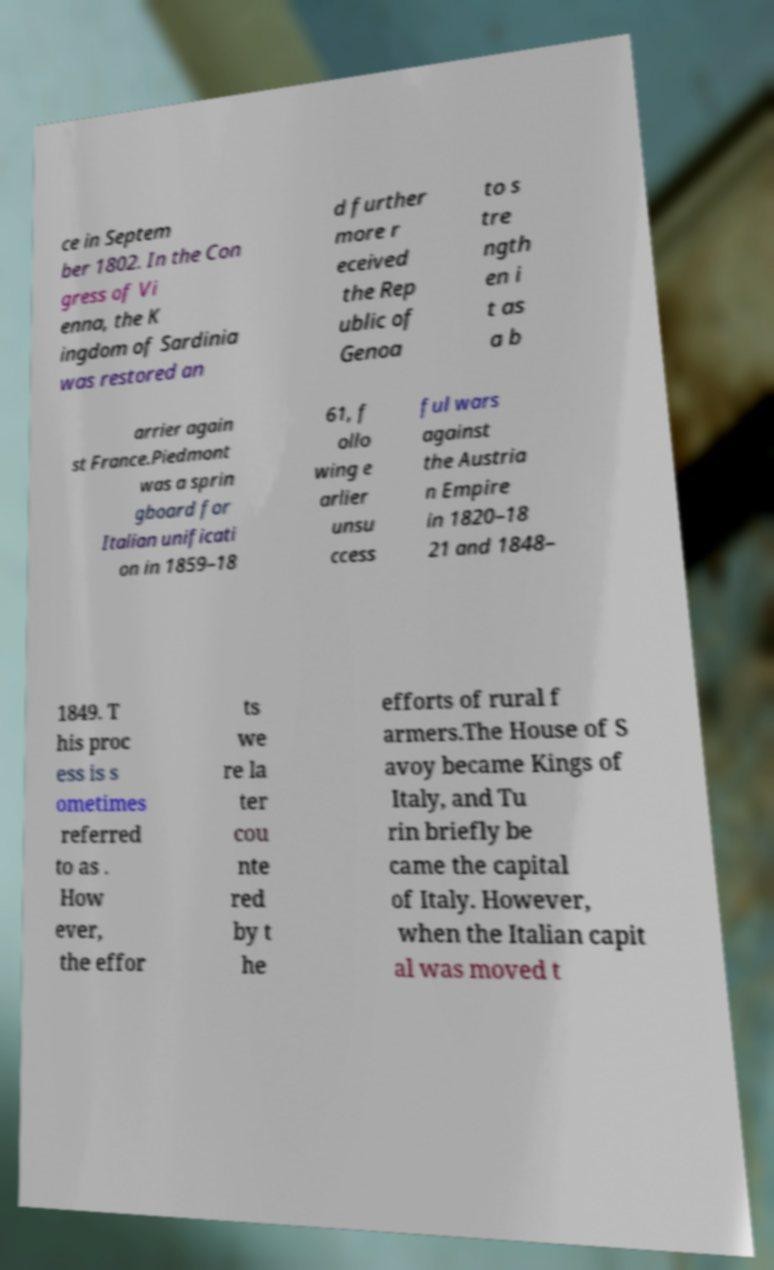For documentation purposes, I need the text within this image transcribed. Could you provide that? ce in Septem ber 1802. In the Con gress of Vi enna, the K ingdom of Sardinia was restored an d further more r eceived the Rep ublic of Genoa to s tre ngth en i t as a b arrier again st France.Piedmont was a sprin gboard for Italian unificati on in 1859–18 61, f ollo wing e arlier unsu ccess ful wars against the Austria n Empire in 1820–18 21 and 1848– 1849. T his proc ess is s ometimes referred to as . How ever, the effor ts we re la ter cou nte red by t he efforts of rural f armers.The House of S avoy became Kings of Italy, and Tu rin briefly be came the capital of Italy. However, when the Italian capit al was moved t 